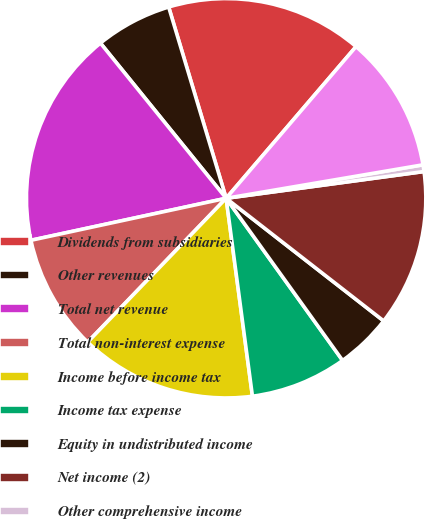<chart> <loc_0><loc_0><loc_500><loc_500><pie_chart><fcel>Dividends from subsidiaries<fcel>Other revenues<fcel>Total net revenue<fcel>Total non-interest expense<fcel>Income before income tax<fcel>Income tax expense<fcel>Equity in undistributed income<fcel>Net income (2)<fcel>Other comprehensive income<fcel>Comprehensive income<nl><fcel>15.92%<fcel>6.19%<fcel>17.54%<fcel>9.43%<fcel>14.3%<fcel>7.81%<fcel>4.56%<fcel>12.67%<fcel>0.54%<fcel>11.05%<nl></chart> 